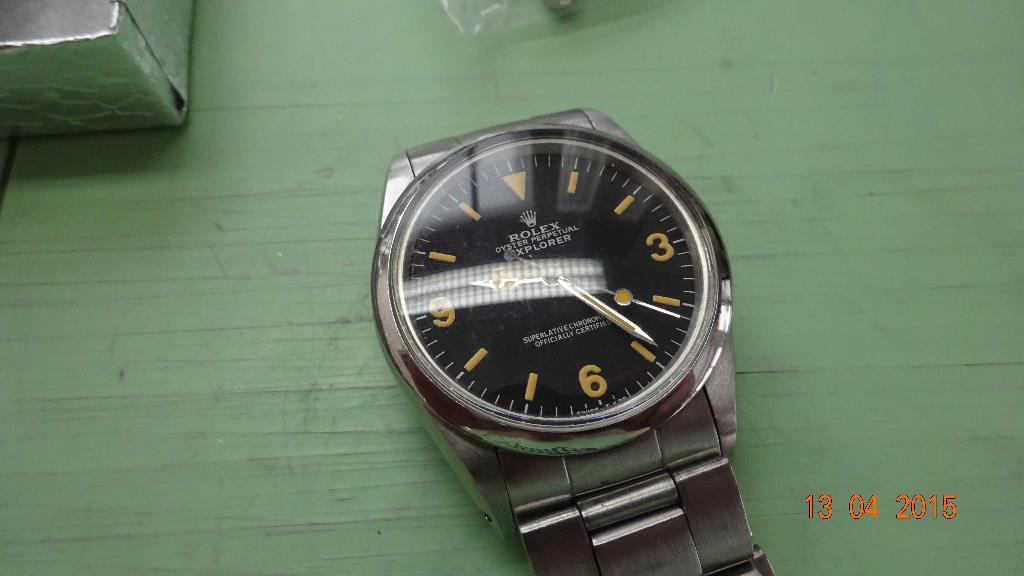<image>
Provide a brief description of the given image. The watch shown is a Rolex and it is oyster propelled, 